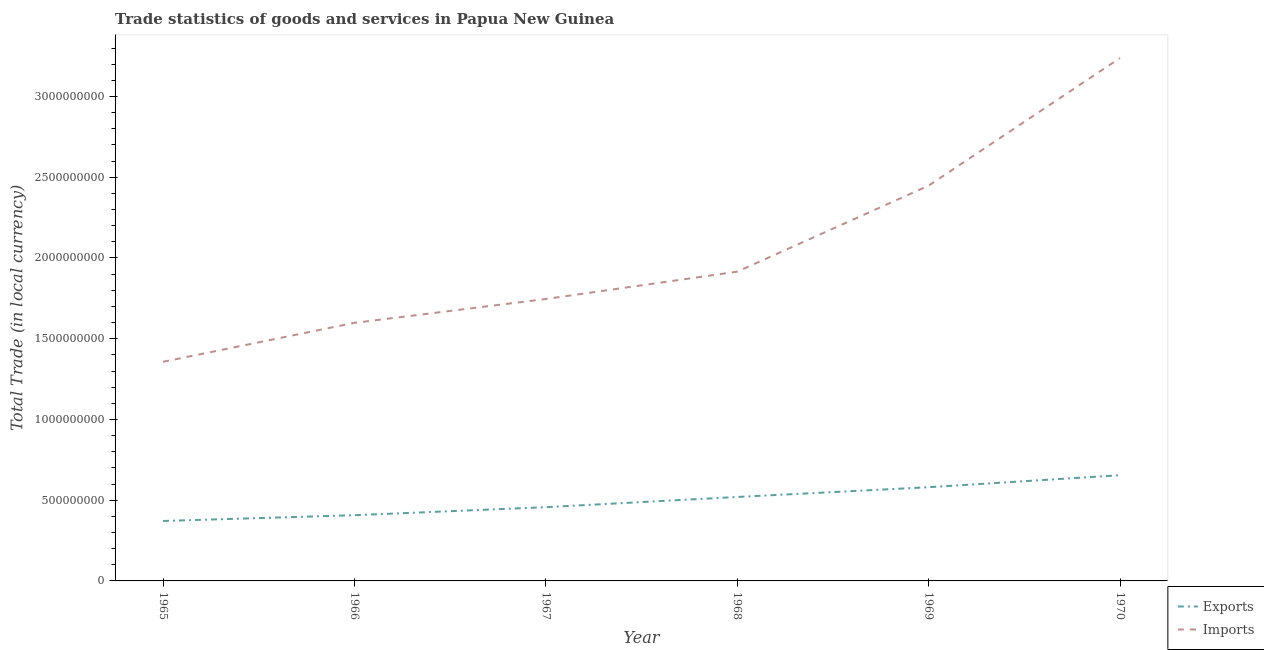Does the line corresponding to export of goods and services intersect with the line corresponding to imports of goods and services?
Ensure brevity in your answer.  No. Is the number of lines equal to the number of legend labels?
Your response must be concise. Yes. What is the export of goods and services in 1969?
Offer a very short reply. 5.80e+08. Across all years, what is the maximum export of goods and services?
Keep it short and to the point. 6.55e+08. Across all years, what is the minimum export of goods and services?
Your answer should be very brief. 3.71e+08. In which year was the export of goods and services maximum?
Provide a succinct answer. 1970. In which year was the export of goods and services minimum?
Give a very brief answer. 1965. What is the total export of goods and services in the graph?
Make the answer very short. 2.99e+09. What is the difference between the export of goods and services in 1967 and that in 1970?
Provide a short and direct response. -1.98e+08. What is the difference between the export of goods and services in 1966 and the imports of goods and services in 1967?
Your answer should be very brief. -1.34e+09. What is the average export of goods and services per year?
Provide a short and direct response. 4.98e+08. In the year 1970, what is the difference between the export of goods and services and imports of goods and services?
Your response must be concise. -2.58e+09. What is the ratio of the export of goods and services in 1968 to that in 1970?
Offer a very short reply. 0.79. Is the difference between the imports of goods and services in 1967 and 1970 greater than the difference between the export of goods and services in 1967 and 1970?
Give a very brief answer. No. What is the difference between the highest and the second highest imports of goods and services?
Your response must be concise. 7.90e+08. What is the difference between the highest and the lowest export of goods and services?
Keep it short and to the point. 2.84e+08. In how many years, is the imports of goods and services greater than the average imports of goods and services taken over all years?
Offer a very short reply. 2. Does the imports of goods and services monotonically increase over the years?
Offer a terse response. Yes. Is the export of goods and services strictly greater than the imports of goods and services over the years?
Ensure brevity in your answer.  No. Is the export of goods and services strictly less than the imports of goods and services over the years?
Provide a succinct answer. Yes. How many lines are there?
Give a very brief answer. 2. How many years are there in the graph?
Provide a succinct answer. 6. What is the difference between two consecutive major ticks on the Y-axis?
Offer a terse response. 5.00e+08. How many legend labels are there?
Ensure brevity in your answer.  2. How are the legend labels stacked?
Give a very brief answer. Vertical. What is the title of the graph?
Provide a succinct answer. Trade statistics of goods and services in Papua New Guinea. What is the label or title of the X-axis?
Your answer should be compact. Year. What is the label or title of the Y-axis?
Ensure brevity in your answer.  Total Trade (in local currency). What is the Total Trade (in local currency) in Exports in 1965?
Offer a very short reply. 3.71e+08. What is the Total Trade (in local currency) in Imports in 1965?
Your response must be concise. 1.36e+09. What is the Total Trade (in local currency) of Exports in 1966?
Your answer should be compact. 4.07e+08. What is the Total Trade (in local currency) of Imports in 1966?
Keep it short and to the point. 1.60e+09. What is the Total Trade (in local currency) of Exports in 1967?
Ensure brevity in your answer.  4.57e+08. What is the Total Trade (in local currency) in Imports in 1967?
Offer a very short reply. 1.75e+09. What is the Total Trade (in local currency) of Exports in 1968?
Give a very brief answer. 5.20e+08. What is the Total Trade (in local currency) in Imports in 1968?
Offer a very short reply. 1.92e+09. What is the Total Trade (in local currency) of Exports in 1969?
Your response must be concise. 5.80e+08. What is the Total Trade (in local currency) in Imports in 1969?
Give a very brief answer. 2.45e+09. What is the Total Trade (in local currency) in Exports in 1970?
Keep it short and to the point. 6.55e+08. What is the Total Trade (in local currency) of Imports in 1970?
Provide a short and direct response. 3.24e+09. Across all years, what is the maximum Total Trade (in local currency) of Exports?
Make the answer very short. 6.55e+08. Across all years, what is the maximum Total Trade (in local currency) in Imports?
Offer a very short reply. 3.24e+09. Across all years, what is the minimum Total Trade (in local currency) of Exports?
Offer a very short reply. 3.71e+08. Across all years, what is the minimum Total Trade (in local currency) in Imports?
Offer a terse response. 1.36e+09. What is the total Total Trade (in local currency) in Exports in the graph?
Your response must be concise. 2.99e+09. What is the total Total Trade (in local currency) in Imports in the graph?
Keep it short and to the point. 1.23e+1. What is the difference between the Total Trade (in local currency) in Exports in 1965 and that in 1966?
Your response must be concise. -3.59e+07. What is the difference between the Total Trade (in local currency) of Imports in 1965 and that in 1966?
Offer a terse response. -2.41e+08. What is the difference between the Total Trade (in local currency) in Exports in 1965 and that in 1967?
Provide a short and direct response. -8.55e+07. What is the difference between the Total Trade (in local currency) in Imports in 1965 and that in 1967?
Offer a terse response. -3.89e+08. What is the difference between the Total Trade (in local currency) of Exports in 1965 and that in 1968?
Offer a very short reply. -1.49e+08. What is the difference between the Total Trade (in local currency) in Imports in 1965 and that in 1968?
Offer a very short reply. -5.58e+08. What is the difference between the Total Trade (in local currency) of Exports in 1965 and that in 1969?
Offer a terse response. -2.09e+08. What is the difference between the Total Trade (in local currency) in Imports in 1965 and that in 1969?
Make the answer very short. -1.09e+09. What is the difference between the Total Trade (in local currency) in Exports in 1965 and that in 1970?
Offer a very short reply. -2.84e+08. What is the difference between the Total Trade (in local currency) in Imports in 1965 and that in 1970?
Your answer should be compact. -1.88e+09. What is the difference between the Total Trade (in local currency) of Exports in 1966 and that in 1967?
Provide a short and direct response. -4.96e+07. What is the difference between the Total Trade (in local currency) in Imports in 1966 and that in 1967?
Give a very brief answer. -1.48e+08. What is the difference between the Total Trade (in local currency) in Exports in 1966 and that in 1968?
Make the answer very short. -1.13e+08. What is the difference between the Total Trade (in local currency) in Imports in 1966 and that in 1968?
Provide a short and direct response. -3.17e+08. What is the difference between the Total Trade (in local currency) in Exports in 1966 and that in 1969?
Keep it short and to the point. -1.73e+08. What is the difference between the Total Trade (in local currency) of Imports in 1966 and that in 1969?
Ensure brevity in your answer.  -8.50e+08. What is the difference between the Total Trade (in local currency) in Exports in 1966 and that in 1970?
Provide a succinct answer. -2.48e+08. What is the difference between the Total Trade (in local currency) in Imports in 1966 and that in 1970?
Your response must be concise. -1.64e+09. What is the difference between the Total Trade (in local currency) in Exports in 1967 and that in 1968?
Provide a short and direct response. -6.33e+07. What is the difference between the Total Trade (in local currency) of Imports in 1967 and that in 1968?
Your response must be concise. -1.69e+08. What is the difference between the Total Trade (in local currency) of Exports in 1967 and that in 1969?
Provide a short and direct response. -1.24e+08. What is the difference between the Total Trade (in local currency) of Imports in 1967 and that in 1969?
Provide a succinct answer. -7.02e+08. What is the difference between the Total Trade (in local currency) of Exports in 1967 and that in 1970?
Ensure brevity in your answer.  -1.98e+08. What is the difference between the Total Trade (in local currency) of Imports in 1967 and that in 1970?
Give a very brief answer. -1.49e+09. What is the difference between the Total Trade (in local currency) in Exports in 1968 and that in 1969?
Your response must be concise. -6.05e+07. What is the difference between the Total Trade (in local currency) in Imports in 1968 and that in 1969?
Make the answer very short. -5.33e+08. What is the difference between the Total Trade (in local currency) in Exports in 1968 and that in 1970?
Your response must be concise. -1.35e+08. What is the difference between the Total Trade (in local currency) of Imports in 1968 and that in 1970?
Provide a succinct answer. -1.32e+09. What is the difference between the Total Trade (in local currency) in Exports in 1969 and that in 1970?
Offer a very short reply. -7.42e+07. What is the difference between the Total Trade (in local currency) in Imports in 1969 and that in 1970?
Provide a short and direct response. -7.90e+08. What is the difference between the Total Trade (in local currency) in Exports in 1965 and the Total Trade (in local currency) in Imports in 1966?
Your answer should be very brief. -1.23e+09. What is the difference between the Total Trade (in local currency) of Exports in 1965 and the Total Trade (in local currency) of Imports in 1967?
Your answer should be compact. -1.37e+09. What is the difference between the Total Trade (in local currency) of Exports in 1965 and the Total Trade (in local currency) of Imports in 1968?
Your answer should be compact. -1.54e+09. What is the difference between the Total Trade (in local currency) of Exports in 1965 and the Total Trade (in local currency) of Imports in 1969?
Offer a very short reply. -2.08e+09. What is the difference between the Total Trade (in local currency) of Exports in 1965 and the Total Trade (in local currency) of Imports in 1970?
Provide a succinct answer. -2.87e+09. What is the difference between the Total Trade (in local currency) of Exports in 1966 and the Total Trade (in local currency) of Imports in 1967?
Provide a succinct answer. -1.34e+09. What is the difference between the Total Trade (in local currency) in Exports in 1966 and the Total Trade (in local currency) in Imports in 1968?
Make the answer very short. -1.51e+09. What is the difference between the Total Trade (in local currency) in Exports in 1966 and the Total Trade (in local currency) in Imports in 1969?
Offer a very short reply. -2.04e+09. What is the difference between the Total Trade (in local currency) of Exports in 1966 and the Total Trade (in local currency) of Imports in 1970?
Your response must be concise. -2.83e+09. What is the difference between the Total Trade (in local currency) of Exports in 1967 and the Total Trade (in local currency) of Imports in 1968?
Offer a terse response. -1.46e+09. What is the difference between the Total Trade (in local currency) in Exports in 1967 and the Total Trade (in local currency) in Imports in 1969?
Your answer should be very brief. -1.99e+09. What is the difference between the Total Trade (in local currency) of Exports in 1967 and the Total Trade (in local currency) of Imports in 1970?
Your answer should be compact. -2.78e+09. What is the difference between the Total Trade (in local currency) of Exports in 1968 and the Total Trade (in local currency) of Imports in 1969?
Make the answer very short. -1.93e+09. What is the difference between the Total Trade (in local currency) in Exports in 1968 and the Total Trade (in local currency) in Imports in 1970?
Offer a terse response. -2.72e+09. What is the difference between the Total Trade (in local currency) of Exports in 1969 and the Total Trade (in local currency) of Imports in 1970?
Provide a short and direct response. -2.66e+09. What is the average Total Trade (in local currency) of Exports per year?
Your answer should be compact. 4.98e+08. What is the average Total Trade (in local currency) in Imports per year?
Provide a short and direct response. 2.05e+09. In the year 1965, what is the difference between the Total Trade (in local currency) of Exports and Total Trade (in local currency) of Imports?
Give a very brief answer. -9.86e+08. In the year 1966, what is the difference between the Total Trade (in local currency) of Exports and Total Trade (in local currency) of Imports?
Ensure brevity in your answer.  -1.19e+09. In the year 1967, what is the difference between the Total Trade (in local currency) in Exports and Total Trade (in local currency) in Imports?
Your answer should be compact. -1.29e+09. In the year 1968, what is the difference between the Total Trade (in local currency) in Exports and Total Trade (in local currency) in Imports?
Offer a very short reply. -1.40e+09. In the year 1969, what is the difference between the Total Trade (in local currency) in Exports and Total Trade (in local currency) in Imports?
Ensure brevity in your answer.  -1.87e+09. In the year 1970, what is the difference between the Total Trade (in local currency) of Exports and Total Trade (in local currency) of Imports?
Your response must be concise. -2.58e+09. What is the ratio of the Total Trade (in local currency) in Exports in 1965 to that in 1966?
Make the answer very short. 0.91. What is the ratio of the Total Trade (in local currency) in Imports in 1965 to that in 1966?
Give a very brief answer. 0.85. What is the ratio of the Total Trade (in local currency) of Exports in 1965 to that in 1967?
Offer a very short reply. 0.81. What is the ratio of the Total Trade (in local currency) in Imports in 1965 to that in 1967?
Ensure brevity in your answer.  0.78. What is the ratio of the Total Trade (in local currency) of Exports in 1965 to that in 1968?
Ensure brevity in your answer.  0.71. What is the ratio of the Total Trade (in local currency) of Imports in 1965 to that in 1968?
Provide a succinct answer. 0.71. What is the ratio of the Total Trade (in local currency) of Exports in 1965 to that in 1969?
Your answer should be very brief. 0.64. What is the ratio of the Total Trade (in local currency) in Imports in 1965 to that in 1969?
Keep it short and to the point. 0.55. What is the ratio of the Total Trade (in local currency) of Exports in 1965 to that in 1970?
Make the answer very short. 0.57. What is the ratio of the Total Trade (in local currency) of Imports in 1965 to that in 1970?
Offer a terse response. 0.42. What is the ratio of the Total Trade (in local currency) of Exports in 1966 to that in 1967?
Offer a terse response. 0.89. What is the ratio of the Total Trade (in local currency) in Imports in 1966 to that in 1967?
Your response must be concise. 0.92. What is the ratio of the Total Trade (in local currency) in Exports in 1966 to that in 1968?
Provide a short and direct response. 0.78. What is the ratio of the Total Trade (in local currency) in Imports in 1966 to that in 1968?
Offer a terse response. 0.83. What is the ratio of the Total Trade (in local currency) of Exports in 1966 to that in 1969?
Make the answer very short. 0.7. What is the ratio of the Total Trade (in local currency) of Imports in 1966 to that in 1969?
Make the answer very short. 0.65. What is the ratio of the Total Trade (in local currency) of Exports in 1966 to that in 1970?
Offer a very short reply. 0.62. What is the ratio of the Total Trade (in local currency) of Imports in 1966 to that in 1970?
Offer a very short reply. 0.49. What is the ratio of the Total Trade (in local currency) of Exports in 1967 to that in 1968?
Provide a short and direct response. 0.88. What is the ratio of the Total Trade (in local currency) in Imports in 1967 to that in 1968?
Keep it short and to the point. 0.91. What is the ratio of the Total Trade (in local currency) of Exports in 1967 to that in 1969?
Your response must be concise. 0.79. What is the ratio of the Total Trade (in local currency) in Imports in 1967 to that in 1969?
Provide a short and direct response. 0.71. What is the ratio of the Total Trade (in local currency) in Exports in 1967 to that in 1970?
Offer a very short reply. 0.7. What is the ratio of the Total Trade (in local currency) of Imports in 1967 to that in 1970?
Provide a succinct answer. 0.54. What is the ratio of the Total Trade (in local currency) in Exports in 1968 to that in 1969?
Provide a short and direct response. 0.9. What is the ratio of the Total Trade (in local currency) in Imports in 1968 to that in 1969?
Provide a succinct answer. 0.78. What is the ratio of the Total Trade (in local currency) in Exports in 1968 to that in 1970?
Give a very brief answer. 0.79. What is the ratio of the Total Trade (in local currency) in Imports in 1968 to that in 1970?
Your response must be concise. 0.59. What is the ratio of the Total Trade (in local currency) in Exports in 1969 to that in 1970?
Offer a terse response. 0.89. What is the ratio of the Total Trade (in local currency) of Imports in 1969 to that in 1970?
Your response must be concise. 0.76. What is the difference between the highest and the second highest Total Trade (in local currency) in Exports?
Provide a short and direct response. 7.42e+07. What is the difference between the highest and the second highest Total Trade (in local currency) in Imports?
Ensure brevity in your answer.  7.90e+08. What is the difference between the highest and the lowest Total Trade (in local currency) of Exports?
Give a very brief answer. 2.84e+08. What is the difference between the highest and the lowest Total Trade (in local currency) in Imports?
Offer a terse response. 1.88e+09. 